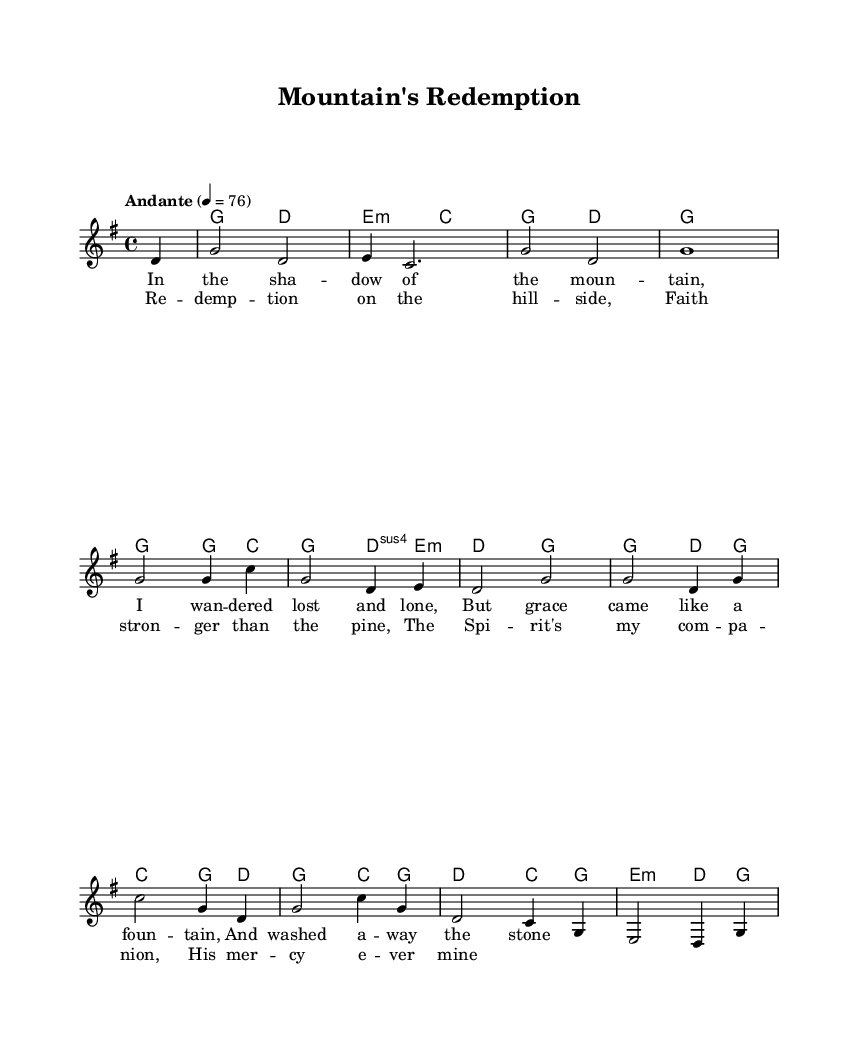What is the key signature of this music? The key signature is G major, which has one sharp (F#).
Answer: G major What is the time signature of this piece? The time signature is 4/4, indicating four beats per measure.
Answer: 4/4 What is the tempo marking for the piece? The tempo marking is "Andante," which suggests a moderate pace.
Answer: Andante What is the first lyric line of the verse? The first lyric line is "In the sha -- dow of the moun -- tain," as indicated in the lyric mode.
Answer: In the shadow of the mountain How many measures does the chorus consist of? The chorus consists of four measures, as it aligns with the structure of the music staff.
Answer: Four measures How does the melody's highest note compare to the lowest note? The highest note in the melody is a G, while the lowest note is a C, indicating a range of a fifth.
Answer: A fifth What thematic element is predominantly explored in this piece? The thematic elements of redemption and faith are conveyed through the lyrics and overall composition style, common in Appalachian spiritual ballads.
Answer: Redemption and faith 